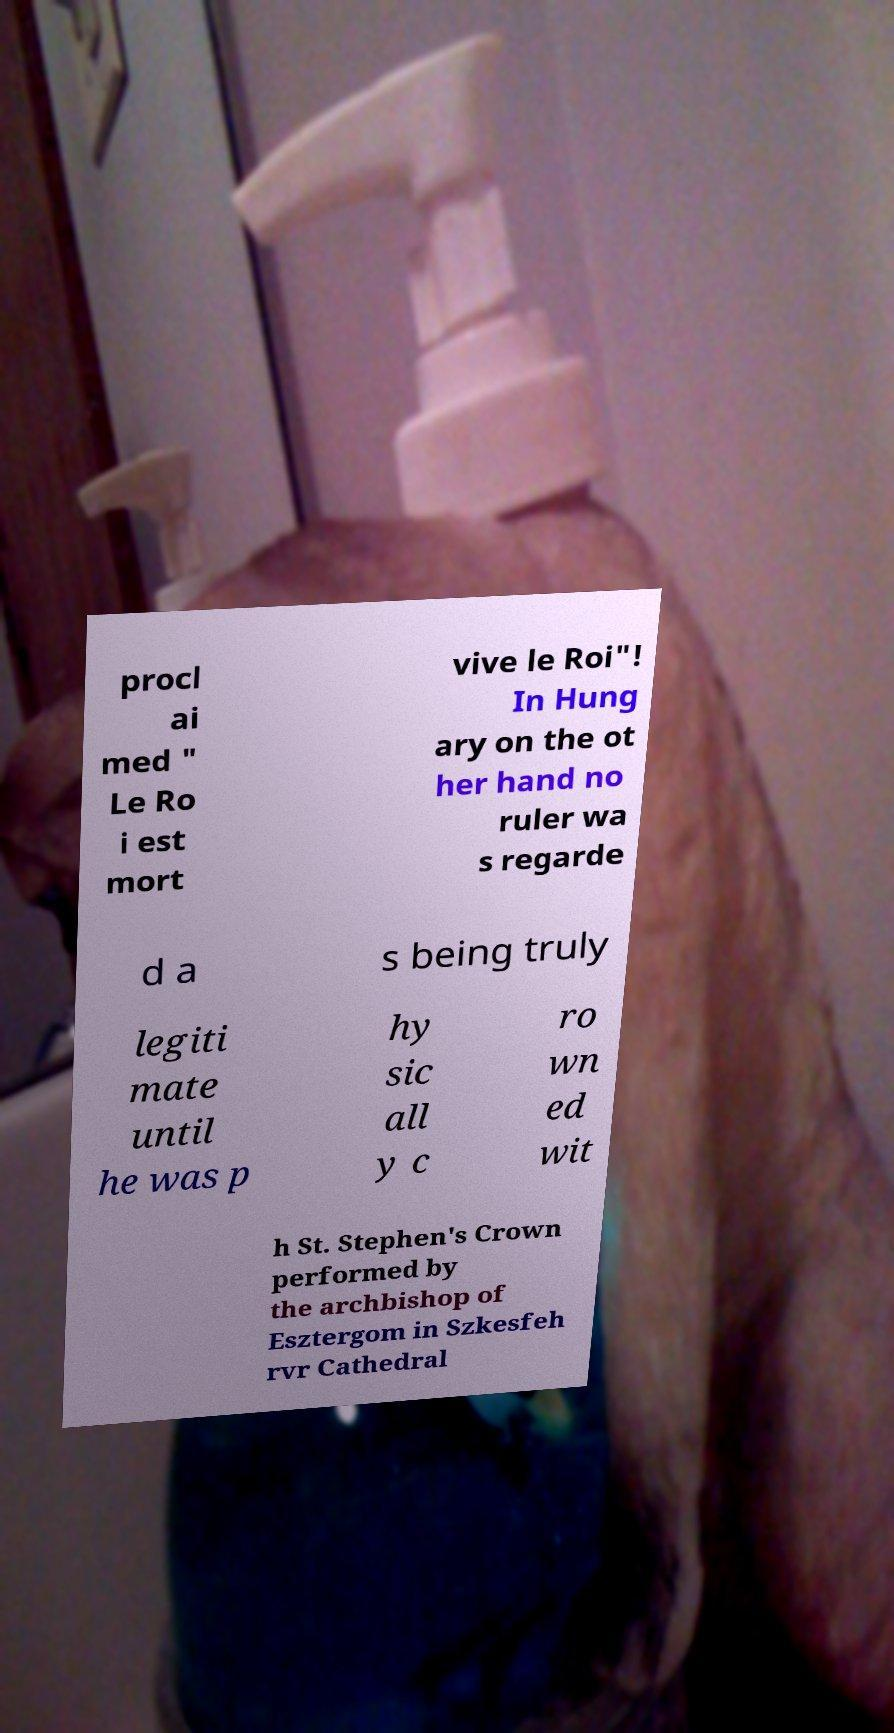There's text embedded in this image that I need extracted. Can you transcribe it verbatim? procl ai med " Le Ro i est mort vive le Roi"! In Hung ary on the ot her hand no ruler wa s regarde d a s being truly legiti mate until he was p hy sic all y c ro wn ed wit h St. Stephen's Crown performed by the archbishop of Esztergom in Szkesfeh rvr Cathedral 